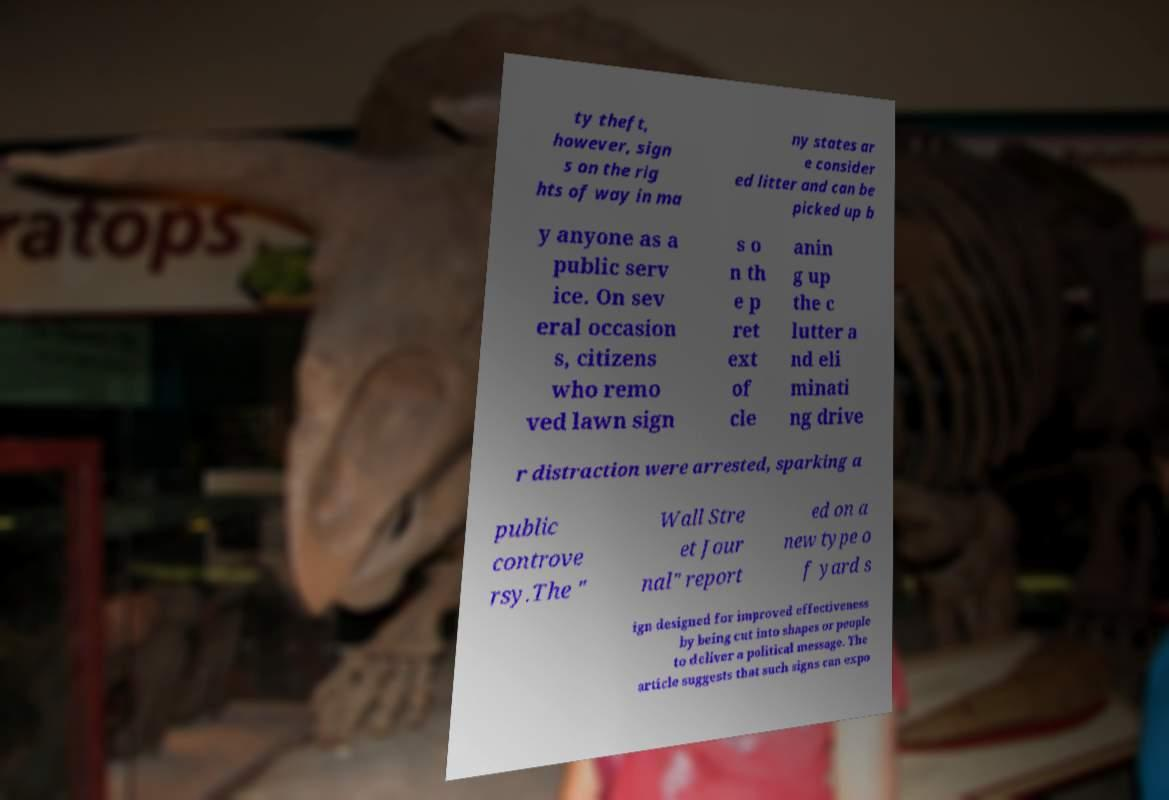I need the written content from this picture converted into text. Can you do that? ty theft, however, sign s on the rig hts of way in ma ny states ar e consider ed litter and can be picked up b y anyone as a public serv ice. On sev eral occasion s, citizens who remo ved lawn sign s o n th e p ret ext of cle anin g up the c lutter a nd eli minati ng drive r distraction were arrested, sparking a public controve rsy.The " Wall Stre et Jour nal" report ed on a new type o f yard s ign designed for improved effectiveness by being cut into shapes or people to deliver a political message. The article suggests that such signs can expo 